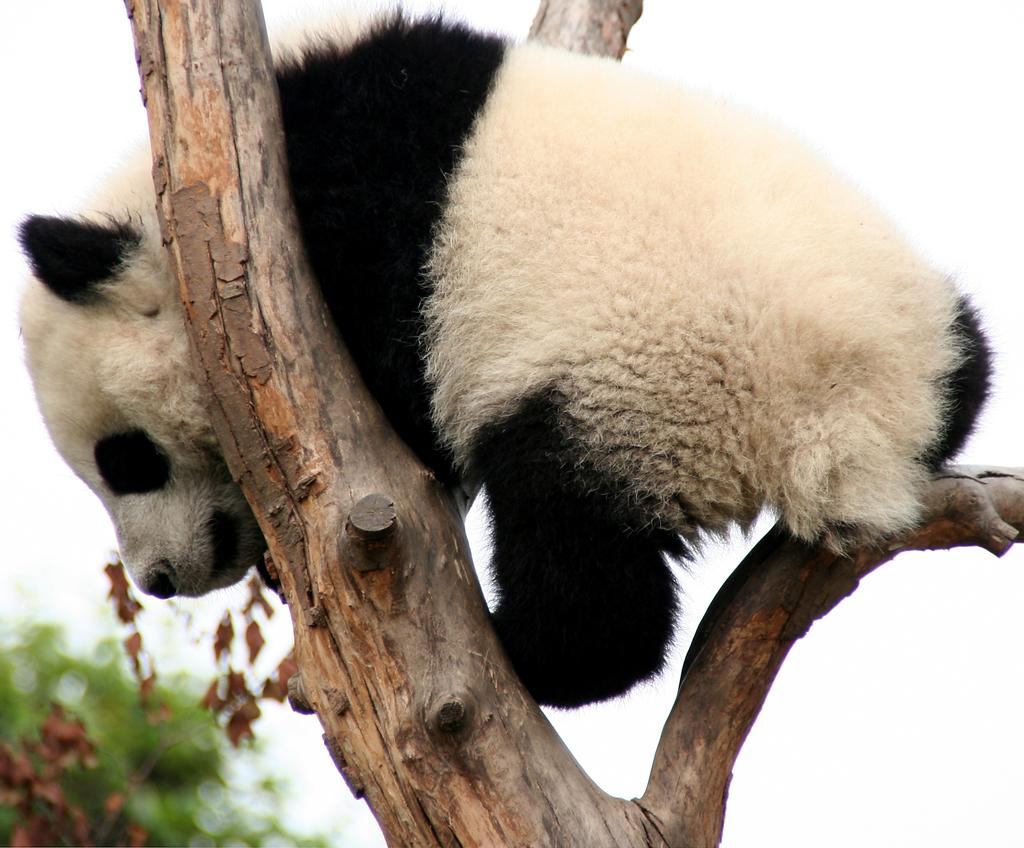Where was the image taken? The image is taken outdoors. What can be seen in the background of the image? There is a tree in the background of the image. What animal is present in the image? There is a panda in the image. Where is the panda located in the image? The panda is on the branch of a tree. What type of frame is around the panda in the image? There is no frame around the panda in the image; it is not a photograph or artwork. 